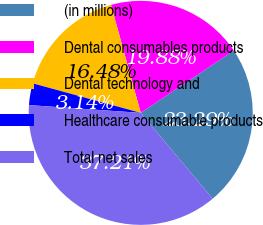<chart> <loc_0><loc_0><loc_500><loc_500><pie_chart><fcel>(in millions)<fcel>Dental consumables products<fcel>Dental technology and<fcel>Healthcare consumable products<fcel>Total net sales<nl><fcel>23.29%<fcel>19.88%<fcel>16.48%<fcel>3.14%<fcel>37.21%<nl></chart> 